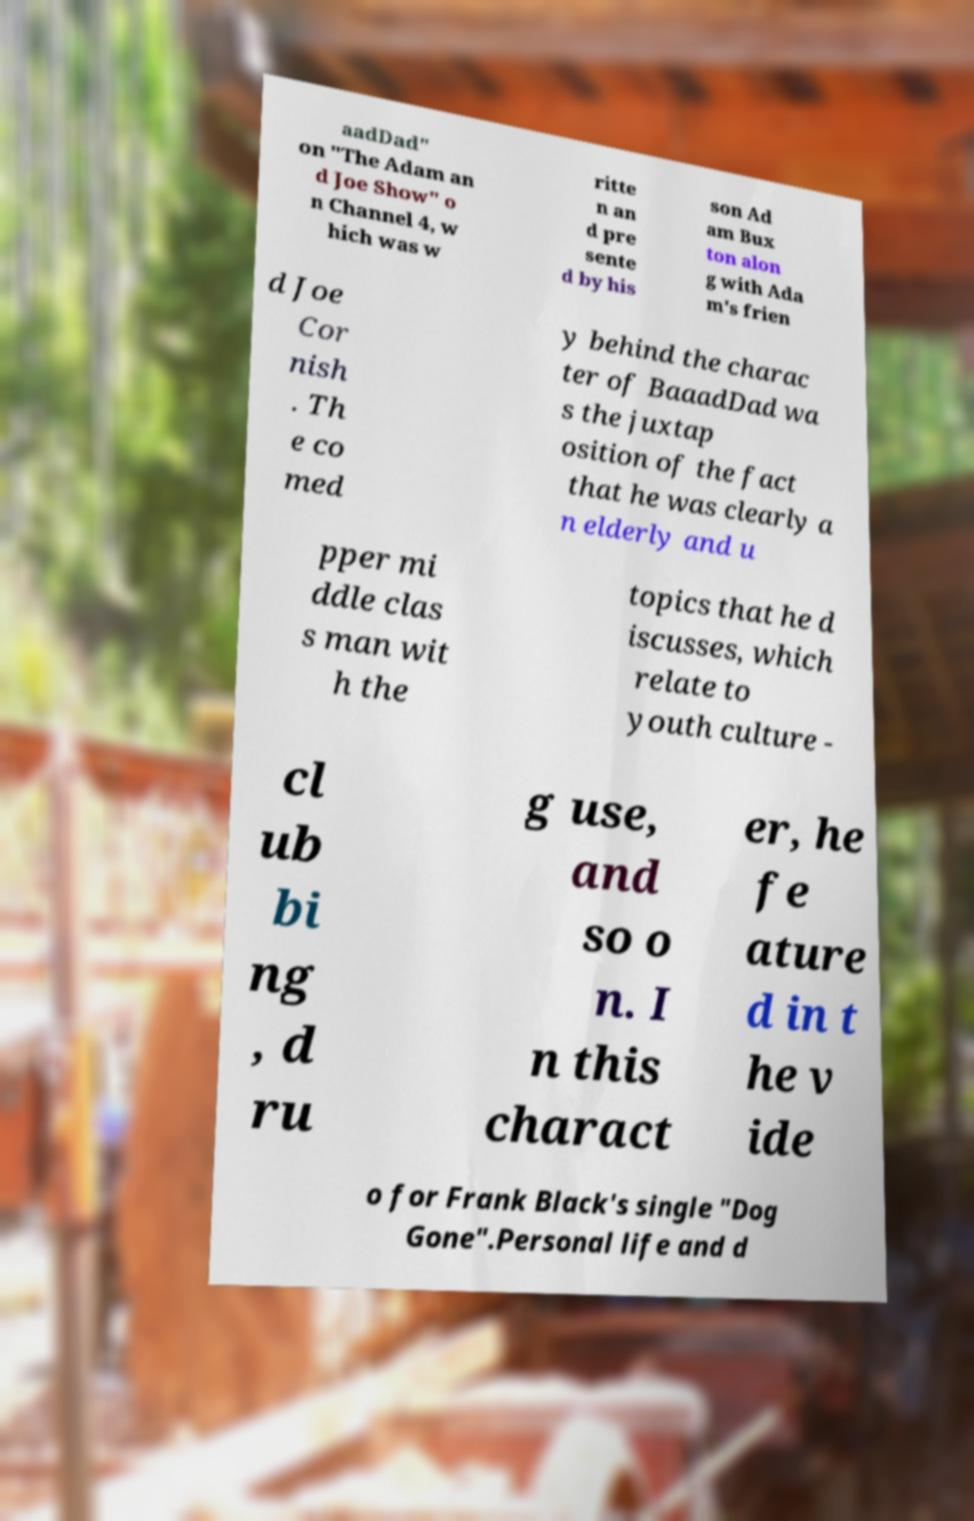Can you read and provide the text displayed in the image?This photo seems to have some interesting text. Can you extract and type it out for me? aadDad" on "The Adam an d Joe Show" o n Channel 4, w hich was w ritte n an d pre sente d by his son Ad am Bux ton alon g with Ada m's frien d Joe Cor nish . Th e co med y behind the charac ter of BaaadDad wa s the juxtap osition of the fact that he was clearly a n elderly and u pper mi ddle clas s man wit h the topics that he d iscusses, which relate to youth culture - cl ub bi ng , d ru g use, and so o n. I n this charact er, he fe ature d in t he v ide o for Frank Black's single "Dog Gone".Personal life and d 